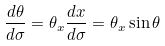Convert formula to latex. <formula><loc_0><loc_0><loc_500><loc_500>\frac { d \theta } { d \sigma } = \theta _ { x } \frac { d x } { d \sigma } = \theta _ { x } \sin \theta</formula> 